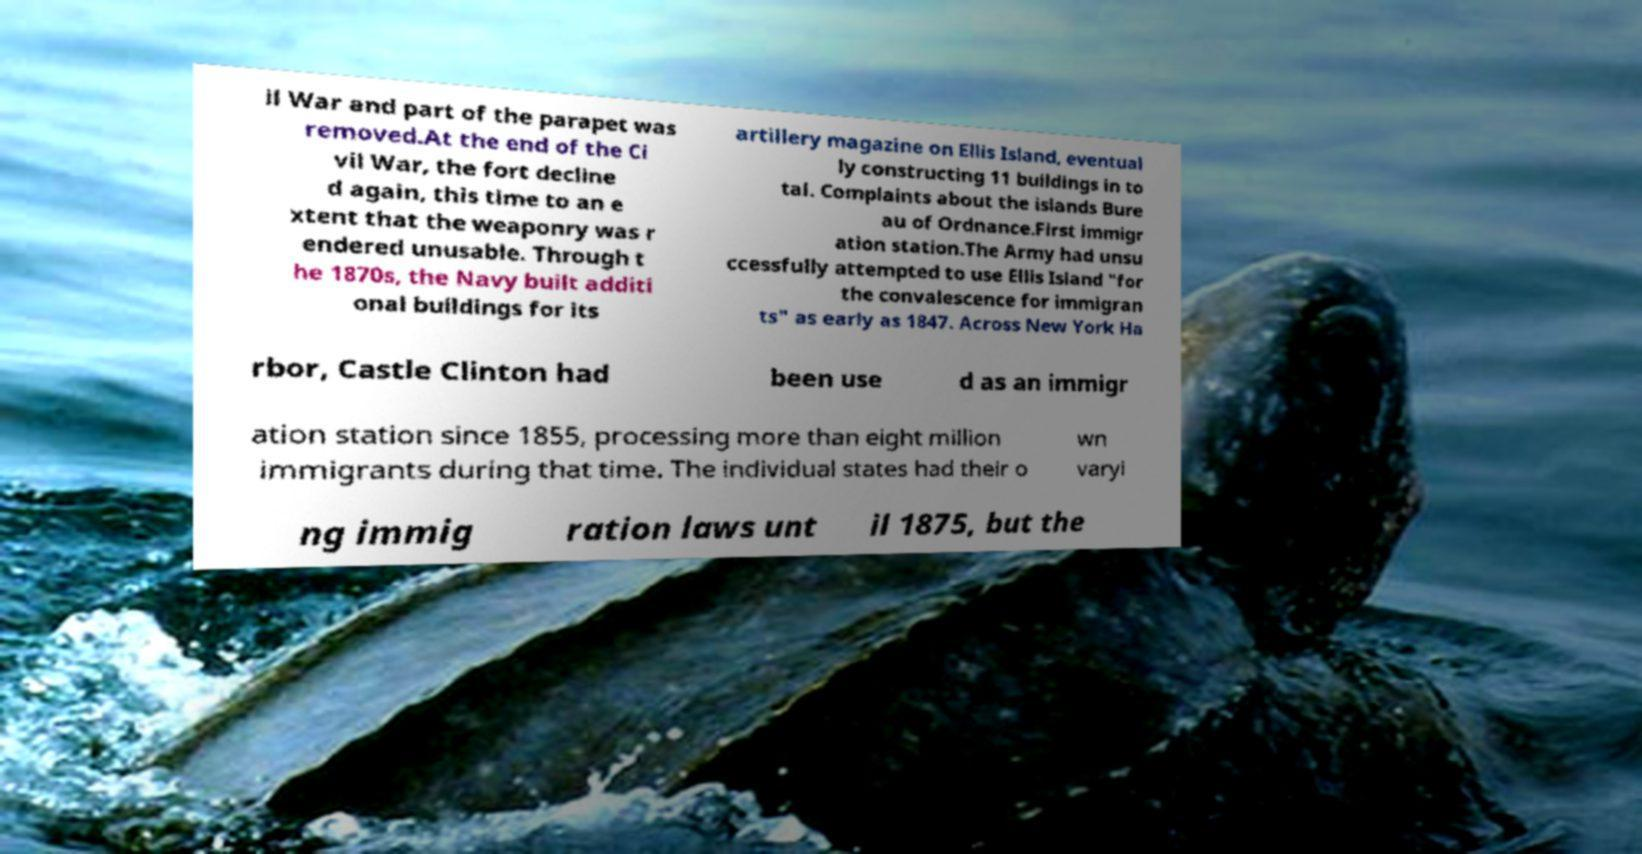There's text embedded in this image that I need extracted. Can you transcribe it verbatim? il War and part of the parapet was removed.At the end of the Ci vil War, the fort decline d again, this time to an e xtent that the weaponry was r endered unusable. Through t he 1870s, the Navy built additi onal buildings for its artillery magazine on Ellis Island, eventual ly constructing 11 buildings in to tal. Complaints about the islands Bure au of Ordnance.First immigr ation station.The Army had unsu ccessfully attempted to use Ellis Island "for the convalescence for immigran ts" as early as 1847. Across New York Ha rbor, Castle Clinton had been use d as an immigr ation station since 1855, processing more than eight million immigrants during that time. The individual states had their o wn varyi ng immig ration laws unt il 1875, but the 